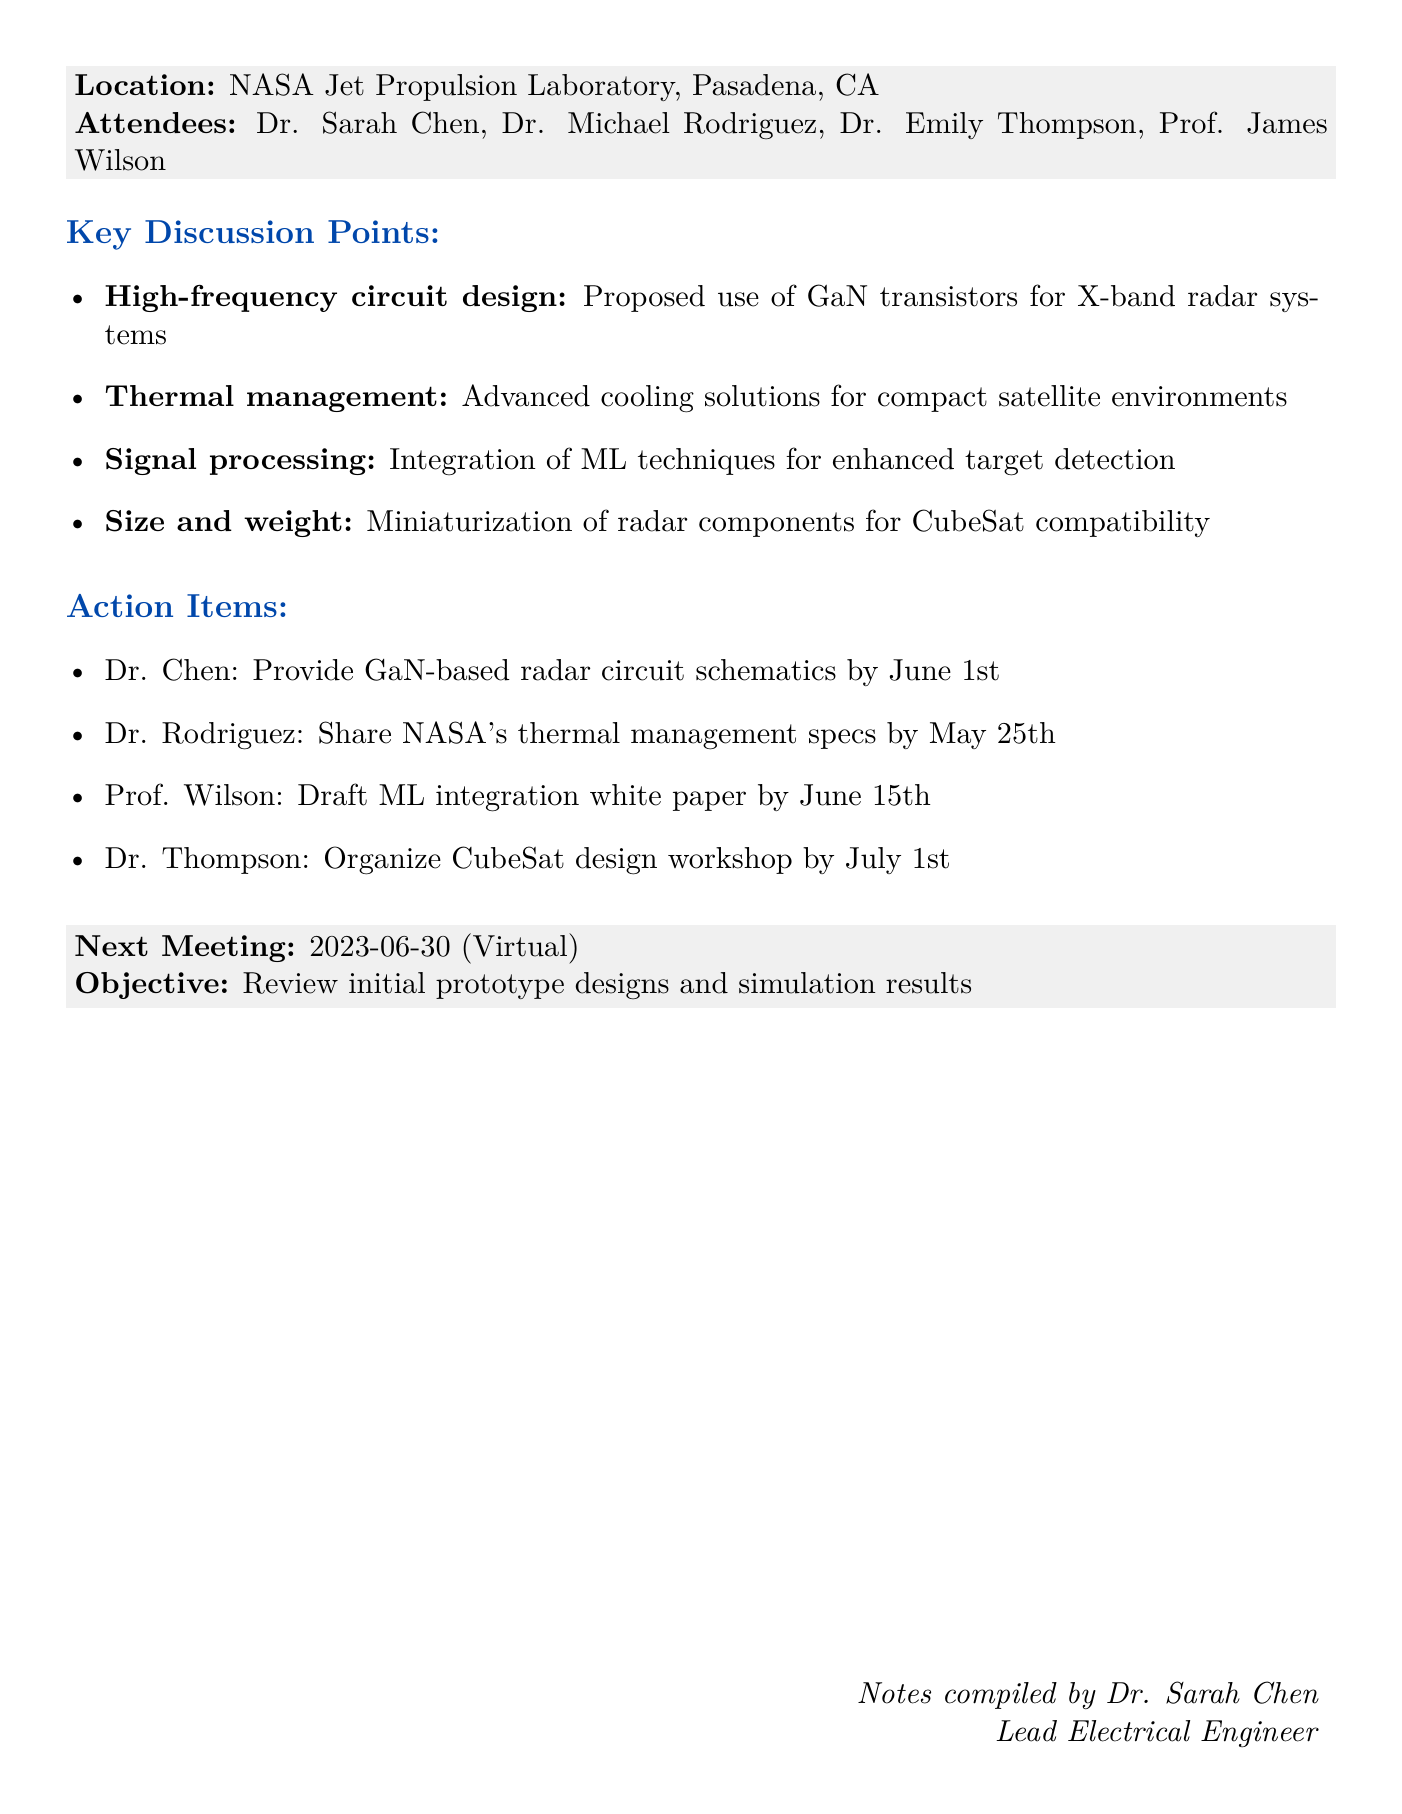What is the date of the meeting? The date of the meeting is explicitly mentioned in the document as May 15, 2023.
Answer: May 15, 2023 Who is the lead electrical engineer? The lead electrical engineer is identified as Dr. Sarah Chen in the document.
Answer: Dr. Sarah Chen What major topic was discussed regarding radar components? The discussion included miniaturization of radar components while maintaining performance for CubeSat compatibility.
Answer: Miniaturization What is the main objective of the next meeting? The main objective of the next meeting is specified as reviewing initial prototype designs and simulation results.
Answer: Review of initial prototype designs and simulation results When is Dr. Chen expected to provide the radar circuit schematics? The document outlines that Dr. Chen must deliver the schematics by June 1st.
Answer: June 1st What technology is proposed for improving power efficiency in radar systems? The document states the proposed technology is Gallium Nitride (GaN) transistors.
Answer: Gallium Nitride (GaN) transistors What need was identified related to thermal management? The document mentions the need for advanced cooling solutions in compact satellite environments.
Answer: Advanced cooling solutions Who is responsible for drafting a white paper on ML integration? Prof. Wilson is tasked with drafting the white paper regarding ML integration in radar signal processing.
Answer: Prof. Wilson What is the location of the next meeting? The upcoming meeting is noted to be held virtually via Zoom.
Answer: Virtual (Zoom) 